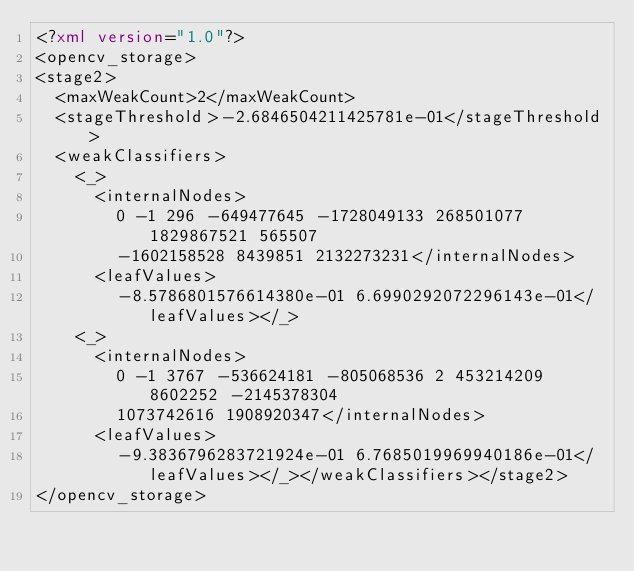Convert code to text. <code><loc_0><loc_0><loc_500><loc_500><_XML_><?xml version="1.0"?>
<opencv_storage>
<stage2>
  <maxWeakCount>2</maxWeakCount>
  <stageThreshold>-2.6846504211425781e-01</stageThreshold>
  <weakClassifiers>
    <_>
      <internalNodes>
        0 -1 296 -649477645 -1728049133 268501077 1829867521 565507
        -1602158528 8439851 2132273231</internalNodes>
      <leafValues>
        -8.5786801576614380e-01 6.6990292072296143e-01</leafValues></_>
    <_>
      <internalNodes>
        0 -1 3767 -536624181 -805068536 2 453214209 8602252 -2145378304
        1073742616 1908920347</internalNodes>
      <leafValues>
        -9.3836796283721924e-01 6.7685019969940186e-01</leafValues></_></weakClassifiers></stage2>
</opencv_storage>
</code> 